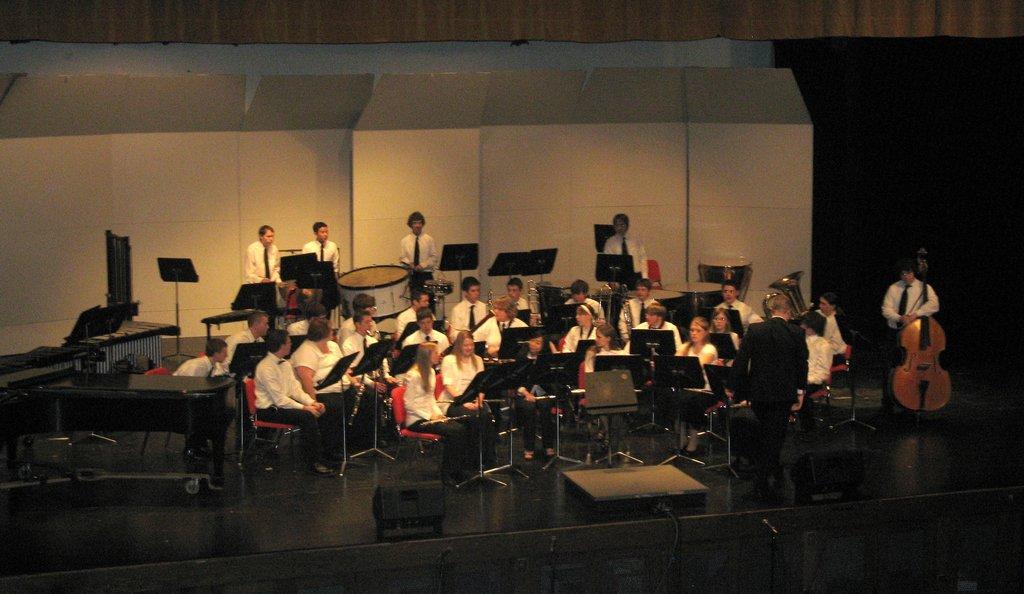In one or two sentences, can you explain what this image depicts? In this image we can see some persons, musical instruments and other objects. In the background of the image there is a wall. At the top of the image there is the ceiling. At the bottom of the image there is a wall and objects. 